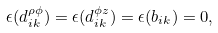<formula> <loc_0><loc_0><loc_500><loc_500>\epsilon ( d ^ { \rho \phi } _ { i k } ) = \epsilon ( d ^ { \phi z } _ { i k } ) = \epsilon ( b _ { i k } ) = 0 ,</formula> 